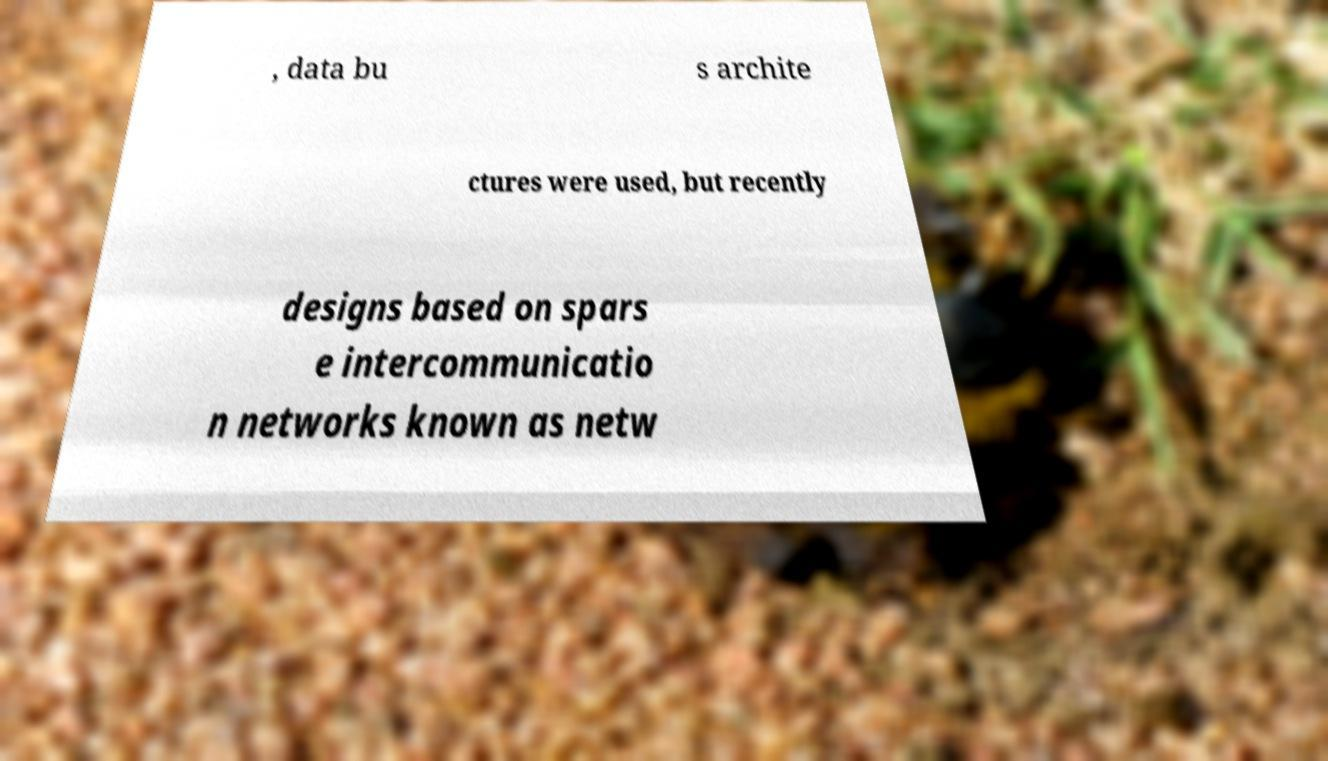Please identify and transcribe the text found in this image. , data bu s archite ctures were used, but recently designs based on spars e intercommunicatio n networks known as netw 